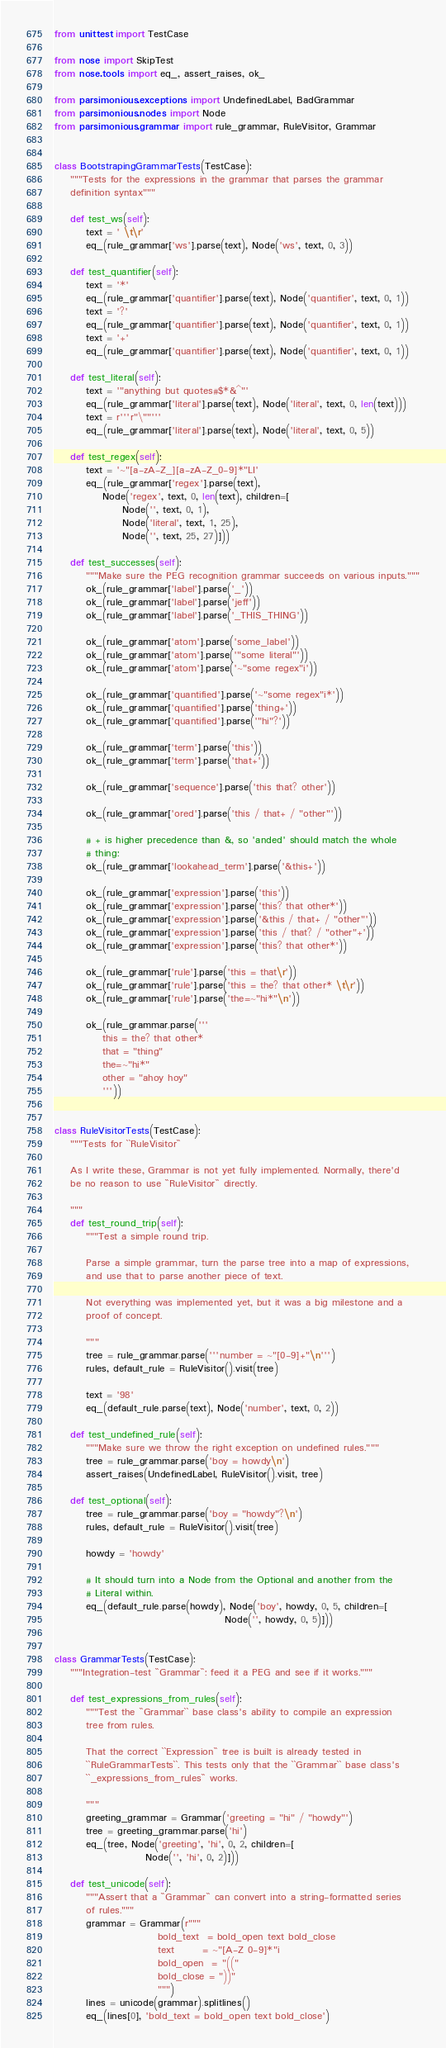Convert code to text. <code><loc_0><loc_0><loc_500><loc_500><_Python_>from unittest import TestCase

from nose import SkipTest
from nose.tools import eq_, assert_raises, ok_

from parsimonious.exceptions import UndefinedLabel, BadGrammar
from parsimonious.nodes import Node
from parsimonious.grammar import rule_grammar, RuleVisitor, Grammar


class BootstrapingGrammarTests(TestCase):
    """Tests for the expressions in the grammar that parses the grammar
    definition syntax"""

    def test_ws(self):
        text = ' \t\r'
        eq_(rule_grammar['ws'].parse(text), Node('ws', text, 0, 3))

    def test_quantifier(self):
        text = '*'
        eq_(rule_grammar['quantifier'].parse(text), Node('quantifier', text, 0, 1))
        text = '?'
        eq_(rule_grammar['quantifier'].parse(text), Node('quantifier', text, 0, 1))
        text = '+'
        eq_(rule_grammar['quantifier'].parse(text), Node('quantifier', text, 0, 1))

    def test_literal(self):
        text = '"anything but quotes#$*&^"'
        eq_(rule_grammar['literal'].parse(text), Node('literal', text, 0, len(text)))
        text = r'''r"\""'''
        eq_(rule_grammar['literal'].parse(text), Node('literal', text, 0, 5))

    def test_regex(self):
        text = '~"[a-zA-Z_][a-zA-Z_0-9]*"LI'
        eq_(rule_grammar['regex'].parse(text),
            Node('regex', text, 0, len(text), children=[
                 Node('', text, 0, 1),
                 Node('literal', text, 1, 25),
                 Node('', text, 25, 27)]))

    def test_successes(self):
        """Make sure the PEG recognition grammar succeeds on various inputs."""
        ok_(rule_grammar['label'].parse('_'))
        ok_(rule_grammar['label'].parse('jeff'))
        ok_(rule_grammar['label'].parse('_THIS_THING'))

        ok_(rule_grammar['atom'].parse('some_label'))
        ok_(rule_grammar['atom'].parse('"some literal"'))
        ok_(rule_grammar['atom'].parse('~"some regex"i'))

        ok_(rule_grammar['quantified'].parse('~"some regex"i*'))
        ok_(rule_grammar['quantified'].parse('thing+'))
        ok_(rule_grammar['quantified'].parse('"hi"?'))

        ok_(rule_grammar['term'].parse('this'))
        ok_(rule_grammar['term'].parse('that+'))

        ok_(rule_grammar['sequence'].parse('this that? other'))

        ok_(rule_grammar['ored'].parse('this / that+ / "other"'))

        # + is higher precedence than &, so 'anded' should match the whole
        # thing:
        ok_(rule_grammar['lookahead_term'].parse('&this+'))

        ok_(rule_grammar['expression'].parse('this'))
        ok_(rule_grammar['expression'].parse('this? that other*'))
        ok_(rule_grammar['expression'].parse('&this / that+ / "other"'))
        ok_(rule_grammar['expression'].parse('this / that? / "other"+'))
        ok_(rule_grammar['expression'].parse('this? that other*'))

        ok_(rule_grammar['rule'].parse('this = that\r'))
        ok_(rule_grammar['rule'].parse('this = the? that other* \t\r'))
        ok_(rule_grammar['rule'].parse('the=~"hi*"\n'))

        ok_(rule_grammar.parse('''
            this = the? that other*
            that = "thing"
            the=~"hi*"
            other = "ahoy hoy"
            '''))


class RuleVisitorTests(TestCase):
    """Tests for ``RuleVisitor``

    As I write these, Grammar is not yet fully implemented. Normally, there'd
    be no reason to use ``RuleVisitor`` directly.

    """
    def test_round_trip(self):
        """Test a simple round trip.

        Parse a simple grammar, turn the parse tree into a map of expressions,
        and use that to parse another piece of text.

        Not everything was implemented yet, but it was a big milestone and a
        proof of concept.

        """
        tree = rule_grammar.parse('''number = ~"[0-9]+"\n''')
        rules, default_rule = RuleVisitor().visit(tree)

        text = '98'
        eq_(default_rule.parse(text), Node('number', text, 0, 2))

    def test_undefined_rule(self):
        """Make sure we throw the right exception on undefined rules."""
        tree = rule_grammar.parse('boy = howdy\n')
        assert_raises(UndefinedLabel, RuleVisitor().visit, tree)

    def test_optional(self):
        tree = rule_grammar.parse('boy = "howdy"?\n')
        rules, default_rule = RuleVisitor().visit(tree)

        howdy = 'howdy'

        # It should turn into a Node from the Optional and another from the
        # Literal within.
        eq_(default_rule.parse(howdy), Node('boy', howdy, 0, 5, children=[
                                           Node('', howdy, 0, 5)]))


class GrammarTests(TestCase):
    """Integration-test ``Grammar``: feed it a PEG and see if it works."""

    def test_expressions_from_rules(self):
        """Test the ``Grammar`` base class's ability to compile an expression
        tree from rules.

        That the correct ``Expression`` tree is built is already tested in
        ``RuleGrammarTests``. This tests only that the ``Grammar`` base class's
        ``_expressions_from_rules`` works.

        """
        greeting_grammar = Grammar('greeting = "hi" / "howdy"')
        tree = greeting_grammar.parse('hi')
        eq_(tree, Node('greeting', 'hi', 0, 2, children=[
                       Node('', 'hi', 0, 2)]))

    def test_unicode(self):
        """Assert that a ``Grammar`` can convert into a string-formatted series
        of rules."""
        grammar = Grammar(r"""
                          bold_text  = bold_open text bold_close
                          text       = ~"[A-Z 0-9]*"i
                          bold_open  = "(("
                          bold_close = "))"
                          """)
        lines = unicode(grammar).splitlines()
        eq_(lines[0], 'bold_text = bold_open text bold_close')</code> 